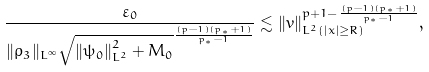Convert formula to latex. <formula><loc_0><loc_0><loc_500><loc_500>\frac { \varepsilon _ { 0 } } { \| \rho _ { 3 } \| _ { L ^ { \infty } } \sqrt { \left \| \psi _ { 0 } \right \| _ { L ^ { 2 } } ^ { 2 } + M _ { 0 } } ^ { \frac { ( p - 1 ) ( p _ { * } + 1 ) } { p _ { * } - 1 } } } \lesssim \| v \| _ { L ^ { 2 } ( | x | \geq R ) } ^ { p + 1 - \frac { ( p - 1 ) ( p _ { * } + 1 ) } { p _ { * } - 1 } } ,</formula> 